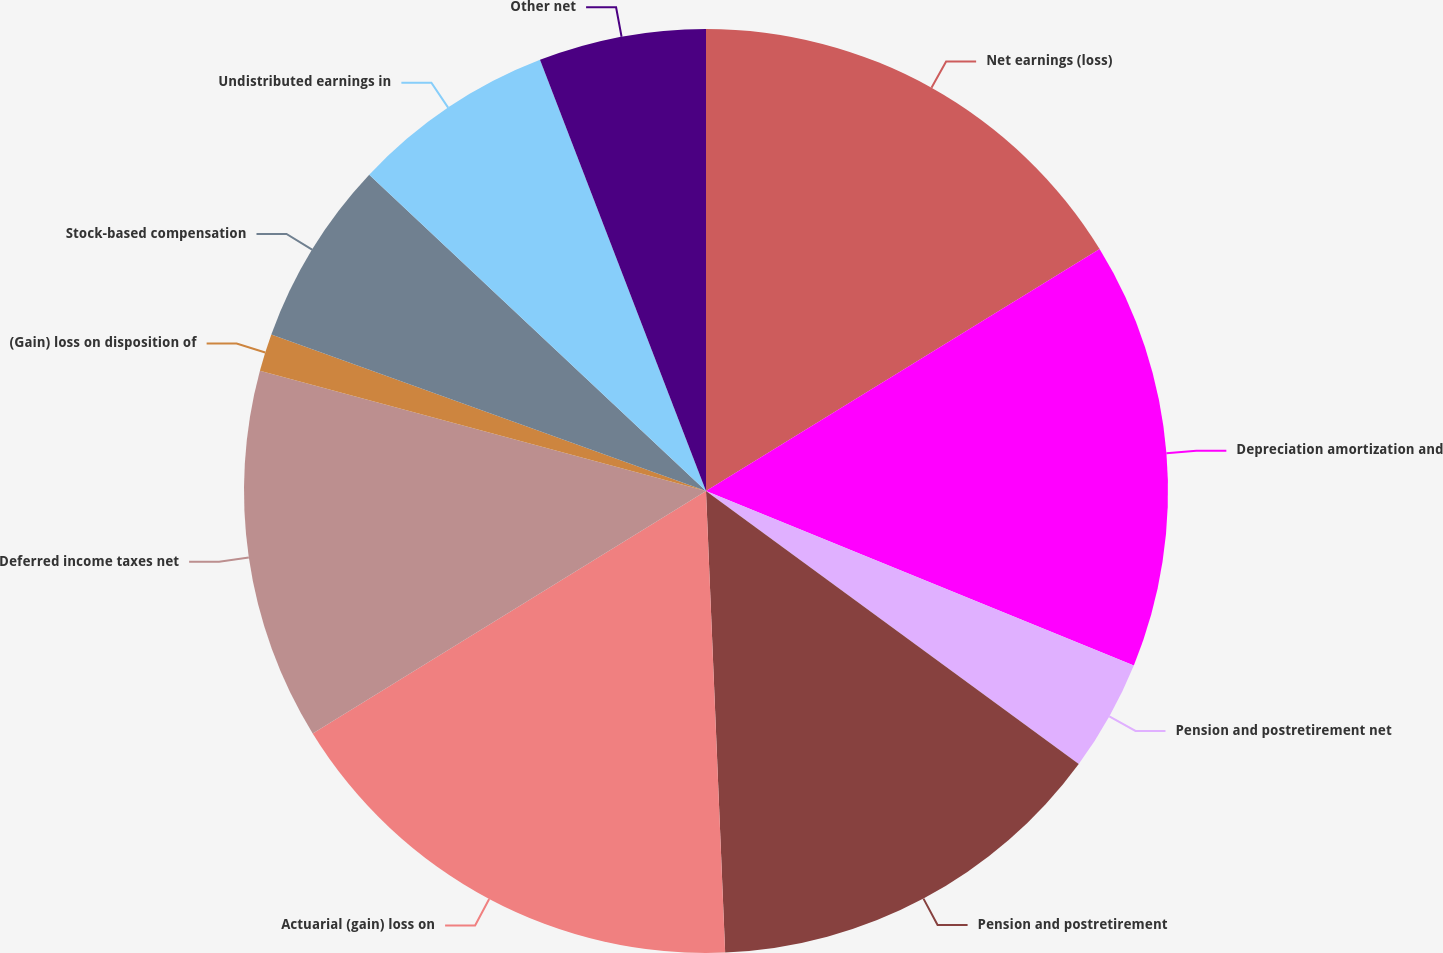Convert chart. <chart><loc_0><loc_0><loc_500><loc_500><pie_chart><fcel>Net earnings (loss)<fcel>Depreciation amortization and<fcel>Pension and postretirement net<fcel>Pension and postretirement<fcel>Actuarial (gain) loss on<fcel>Deferred income taxes net<fcel>(Gain) loss on disposition of<fcel>Stock-based compensation<fcel>Undistributed earnings in<fcel>Other net<nl><fcel>16.23%<fcel>14.93%<fcel>3.9%<fcel>14.28%<fcel>16.87%<fcel>12.98%<fcel>1.31%<fcel>6.5%<fcel>7.15%<fcel>5.85%<nl></chart> 